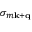Convert formula to latex. <formula><loc_0><loc_0><loc_500><loc_500>\sigma _ { m \mathbf k + \mathbf q }</formula> 